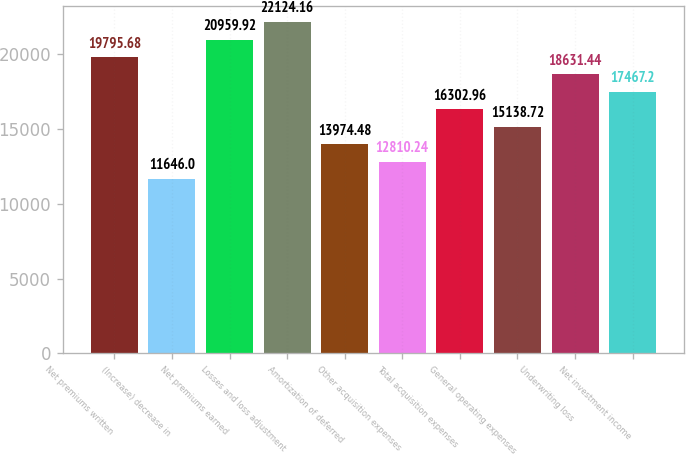Convert chart to OTSL. <chart><loc_0><loc_0><loc_500><loc_500><bar_chart><fcel>Net premiums written<fcel>(Increase) decrease in<fcel>Net premiums earned<fcel>Losses and loss adjustment<fcel>Amortization of deferred<fcel>Other acquisition expenses<fcel>Total acquisition expenses<fcel>General operating expenses<fcel>Underwriting loss<fcel>Net investment income<nl><fcel>19795.7<fcel>11646<fcel>20959.9<fcel>22124.2<fcel>13974.5<fcel>12810.2<fcel>16303<fcel>15138.7<fcel>18631.4<fcel>17467.2<nl></chart> 